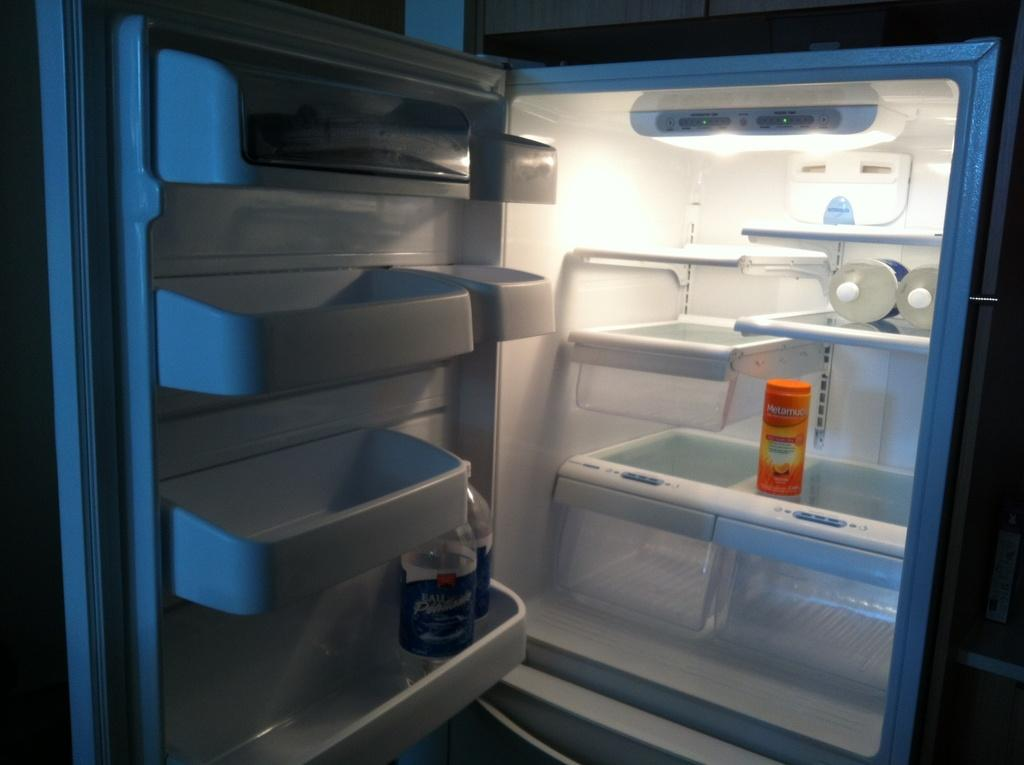<image>
Give a short and clear explanation of the subsequent image. The door of a refrigerator is open, with just a few bottles of water and a container of Metamucil inside. 